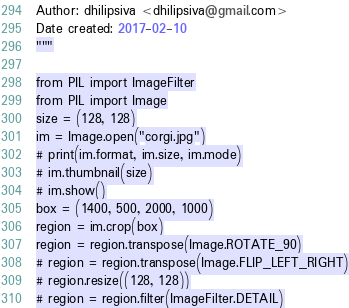Convert code to text. <code><loc_0><loc_0><loc_500><loc_500><_Python_>Author: dhilipsiva <dhilipsiva@gmail.com>
Date created: 2017-02-10
"""

from PIL import ImageFilter
from PIL import Image
size = (128, 128)
im = Image.open("corgi.jpg")
# print(im.format, im.size, im.mode)
# im.thumbnail(size)
# im.show()
box = (1400, 500, 2000, 1000)
region = im.crop(box)
region = region.transpose(Image.ROTATE_90)
# region = region.transpose(Image.FLIP_LEFT_RIGHT)
# region.resize((128, 128))
# region = region.filter(ImageFilter.DETAIL)</code> 